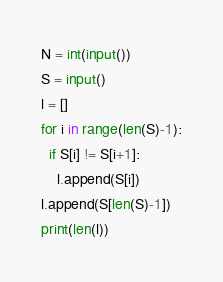Convert code to text. <code><loc_0><loc_0><loc_500><loc_500><_Python_>N = int(input())
S = input()
l = []
for i in range(len(S)-1):
  if S[i] != S[i+1]:
    l.append(S[i])
l.append(S[len(S)-1])
print(len(l))</code> 